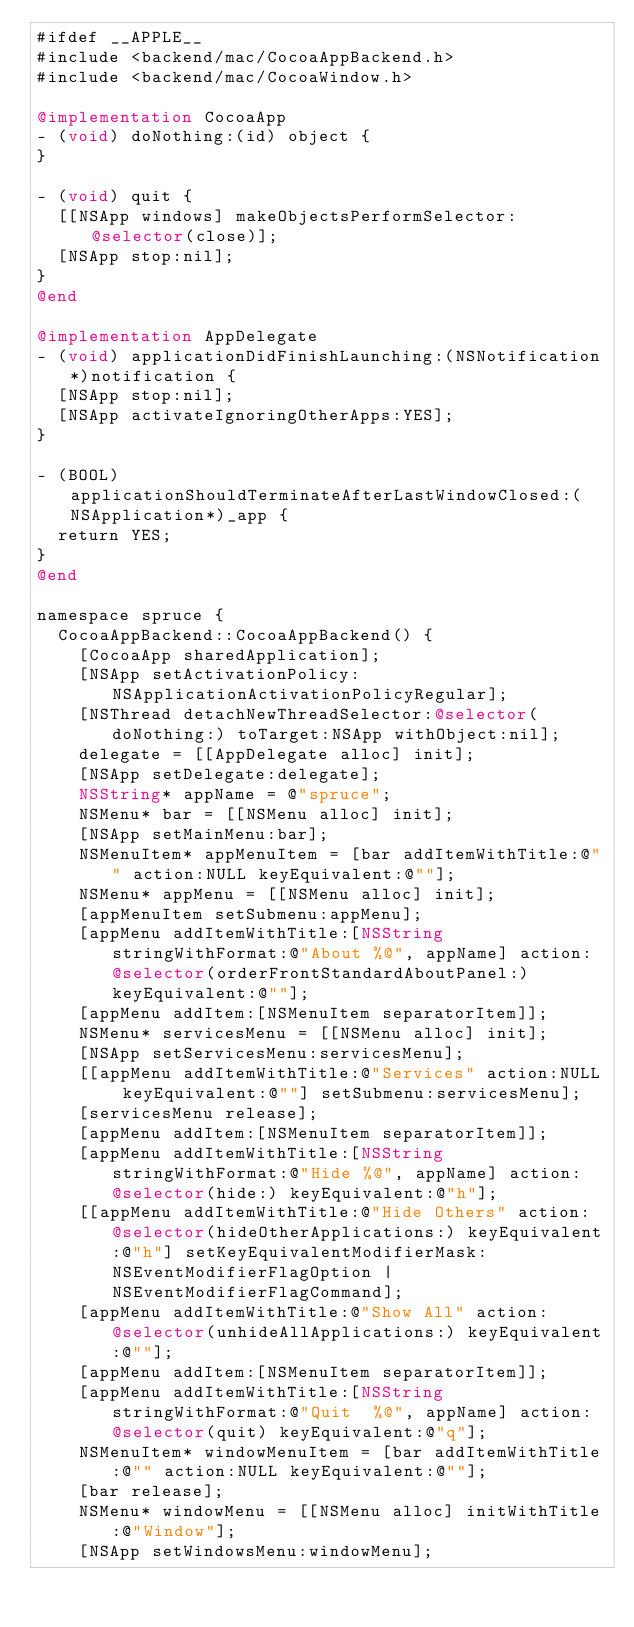Convert code to text. <code><loc_0><loc_0><loc_500><loc_500><_ObjectiveC_>#ifdef __APPLE__
#include <backend/mac/CocoaAppBackend.h>
#include <backend/mac/CocoaWindow.h>

@implementation CocoaApp
- (void) doNothing:(id) object {
}

- (void) quit {
	[[NSApp windows] makeObjectsPerformSelector:@selector(close)];
	[NSApp stop:nil];
}
@end

@implementation AppDelegate
- (void) applicationDidFinishLaunching:(NSNotification*)notification {
	[NSApp stop:nil];
	[NSApp activateIgnoringOtherApps:YES];
}

- (BOOL) applicationShouldTerminateAfterLastWindowClosed:(NSApplication*)_app {
	return YES;
}
@end

namespace spruce {
	CocoaAppBackend::CocoaAppBackend() {
		[CocoaApp sharedApplication];
		[NSApp setActivationPolicy:NSApplicationActivationPolicyRegular];
		[NSThread detachNewThreadSelector:@selector(doNothing:) toTarget:NSApp withObject:nil];
		delegate = [[AppDelegate alloc] init];
		[NSApp setDelegate:delegate];
		NSString* appName = @"spruce";
		NSMenu* bar = [[NSMenu alloc] init];
		[NSApp setMainMenu:bar];
		NSMenuItem* appMenuItem = [bar addItemWithTitle:@"" action:NULL keyEquivalent:@""];
		NSMenu* appMenu = [[NSMenu alloc] init];
		[appMenuItem setSubmenu:appMenu];
		[appMenu addItemWithTitle:[NSString stringWithFormat:@"About %@", appName] action:@selector(orderFrontStandardAboutPanel:) keyEquivalent:@""];
		[appMenu addItem:[NSMenuItem separatorItem]];
		NSMenu* servicesMenu = [[NSMenu alloc] init];
		[NSApp setServicesMenu:servicesMenu];
		[[appMenu addItemWithTitle:@"Services" action:NULL keyEquivalent:@""] setSubmenu:servicesMenu];
		[servicesMenu release];
		[appMenu addItem:[NSMenuItem separatorItem]];
		[appMenu addItemWithTitle:[NSString stringWithFormat:@"Hide %@", appName] action:@selector(hide:) keyEquivalent:@"h"];
		[[appMenu addItemWithTitle:@"Hide Others" action:@selector(hideOtherApplications:) keyEquivalent:@"h"] setKeyEquivalentModifierMask:NSEventModifierFlagOption | NSEventModifierFlagCommand];
		[appMenu addItemWithTitle:@"Show All" action:@selector(unhideAllApplications:) keyEquivalent:@""];
		[appMenu addItem:[NSMenuItem separatorItem]];
		[appMenu addItemWithTitle:[NSString stringWithFormat:@"Quit  %@", appName] action:@selector(quit) keyEquivalent:@"q"];
		NSMenuItem* windowMenuItem = [bar addItemWithTitle:@"" action:NULL keyEquivalent:@""];
		[bar release];
		NSMenu* windowMenu = [[NSMenu alloc] initWithTitle:@"Window"];
		[NSApp setWindowsMenu:windowMenu];</code> 